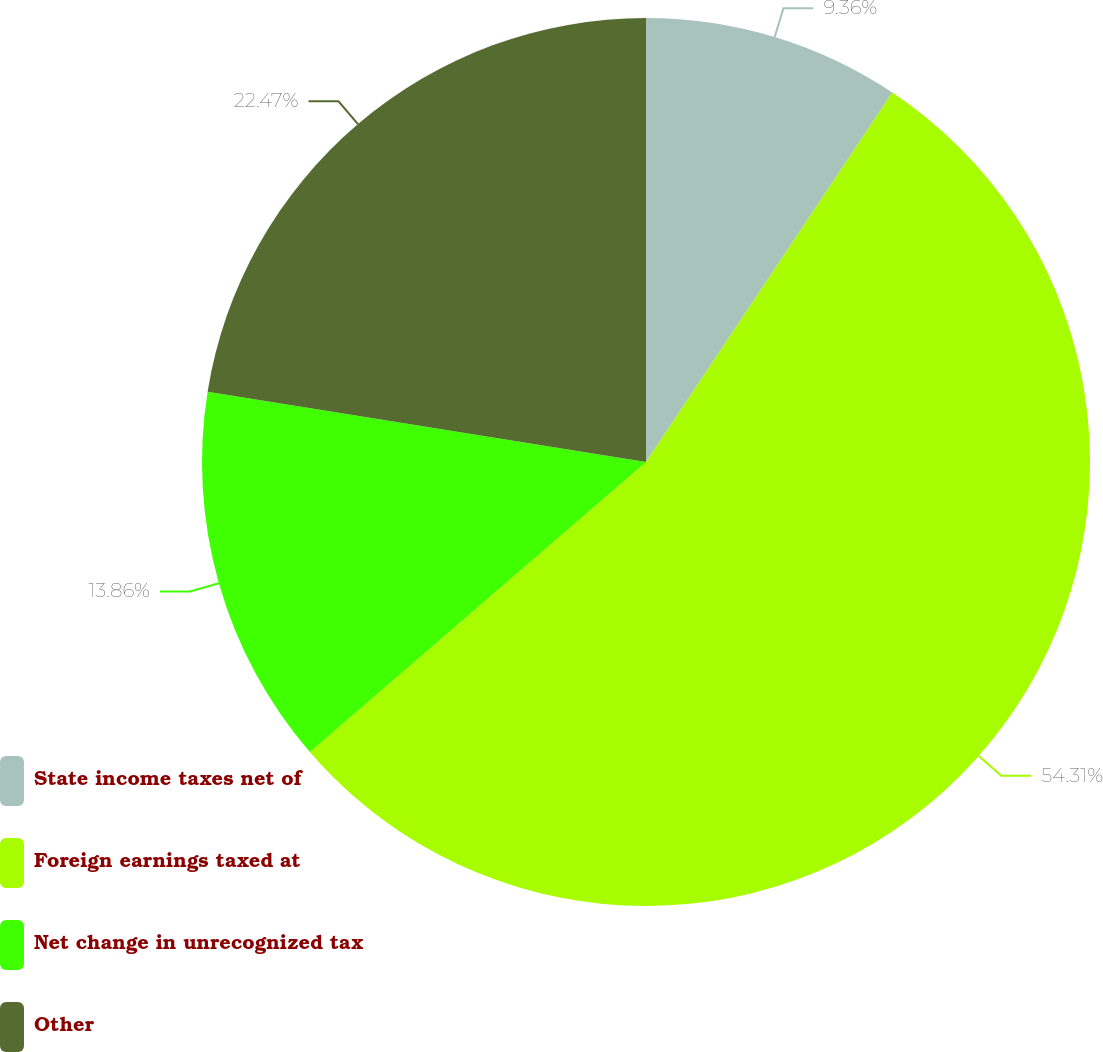<chart> <loc_0><loc_0><loc_500><loc_500><pie_chart><fcel>State income taxes net of<fcel>Foreign earnings taxed at<fcel>Net change in unrecognized tax<fcel>Other<nl><fcel>9.36%<fcel>54.31%<fcel>13.86%<fcel>22.47%<nl></chart> 